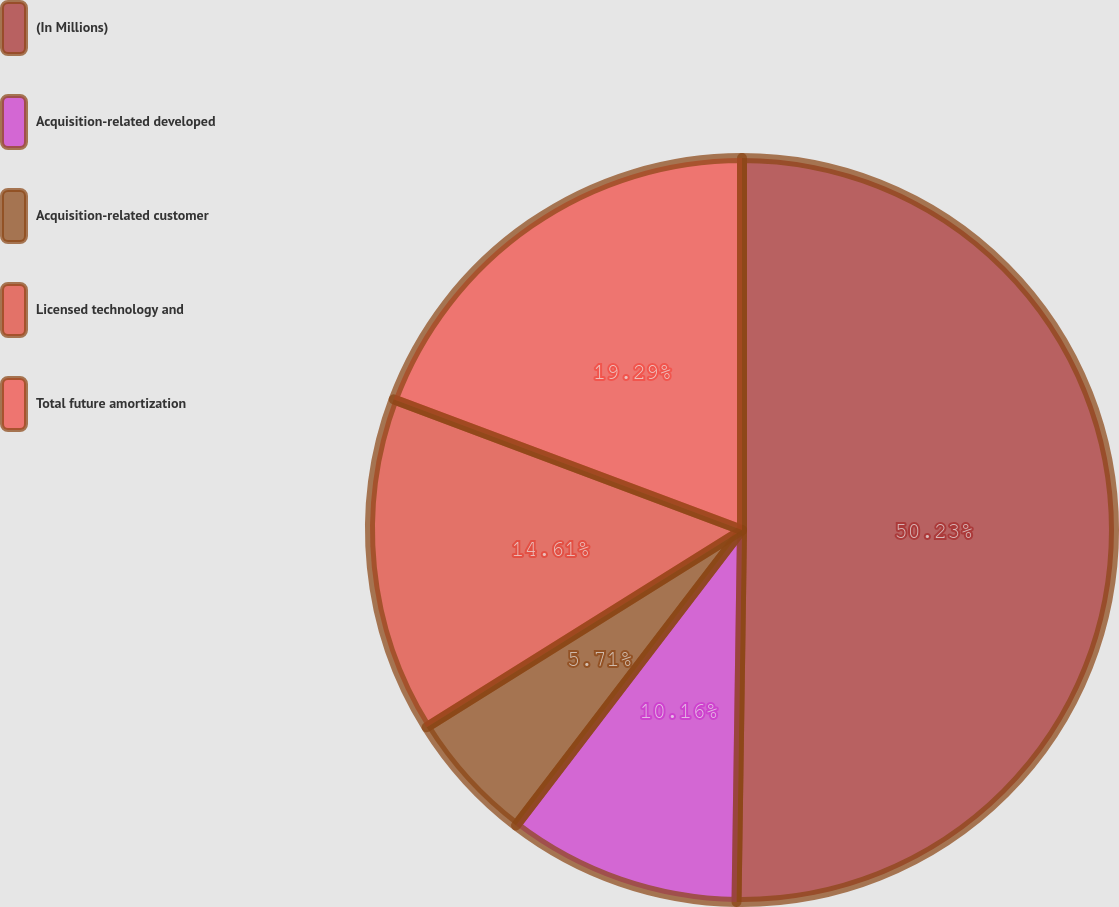Convert chart to OTSL. <chart><loc_0><loc_0><loc_500><loc_500><pie_chart><fcel>(In Millions)<fcel>Acquisition-related developed<fcel>Acquisition-related customer<fcel>Licensed technology and<fcel>Total future amortization<nl><fcel>50.24%<fcel>10.16%<fcel>5.71%<fcel>14.61%<fcel>19.29%<nl></chart> 